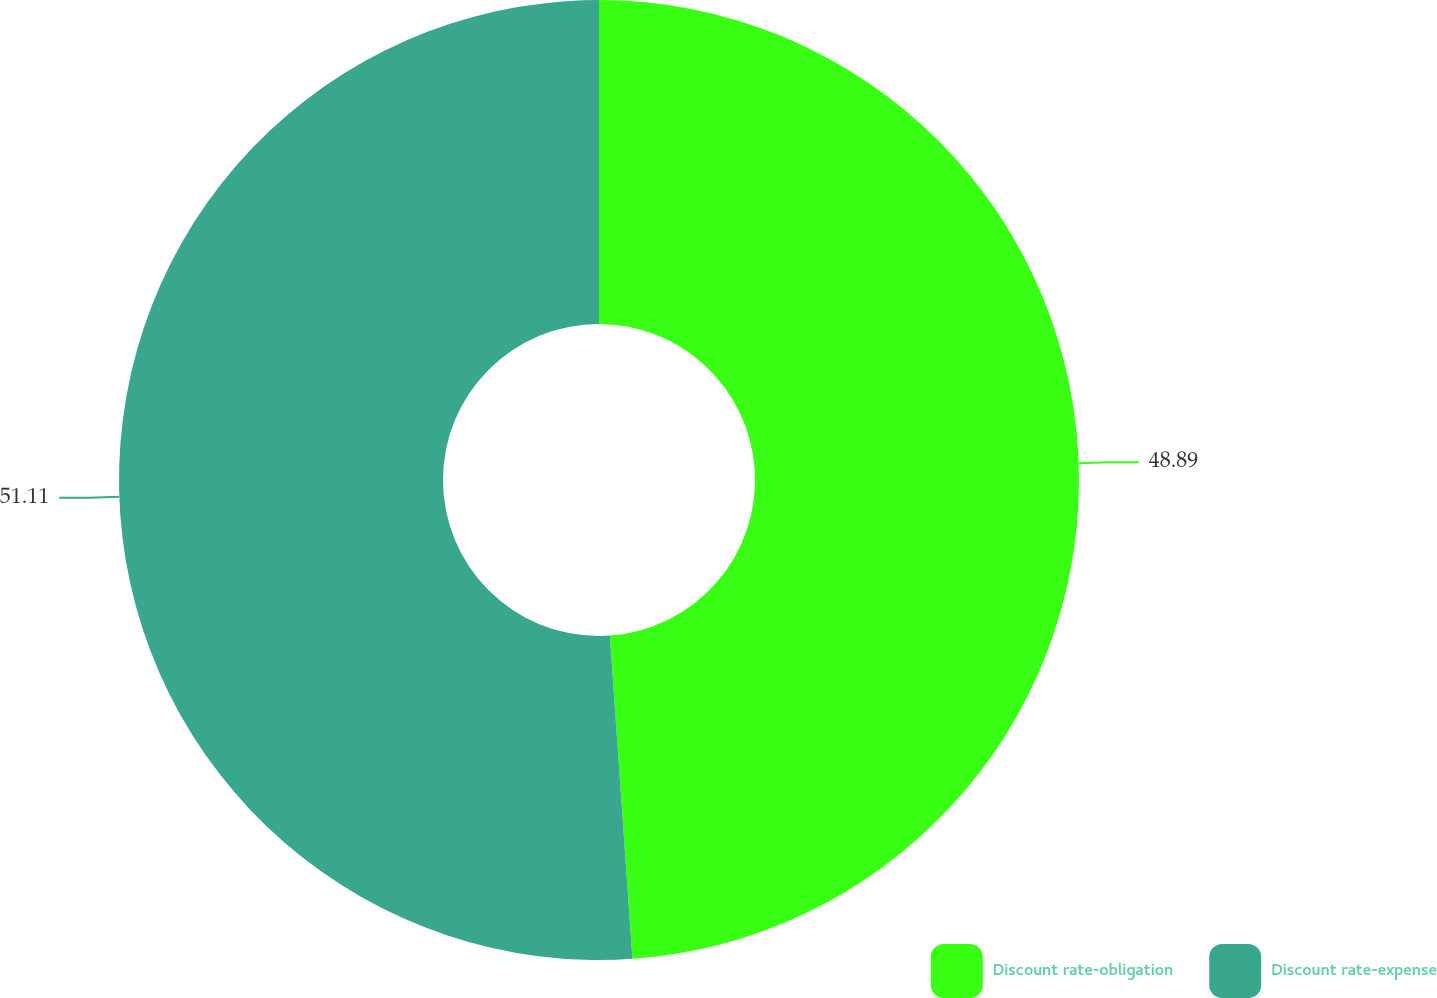Convert chart. <chart><loc_0><loc_0><loc_500><loc_500><pie_chart><fcel>Discount rate-obligation<fcel>Discount rate-expense<nl><fcel>48.89%<fcel>51.11%<nl></chart> 